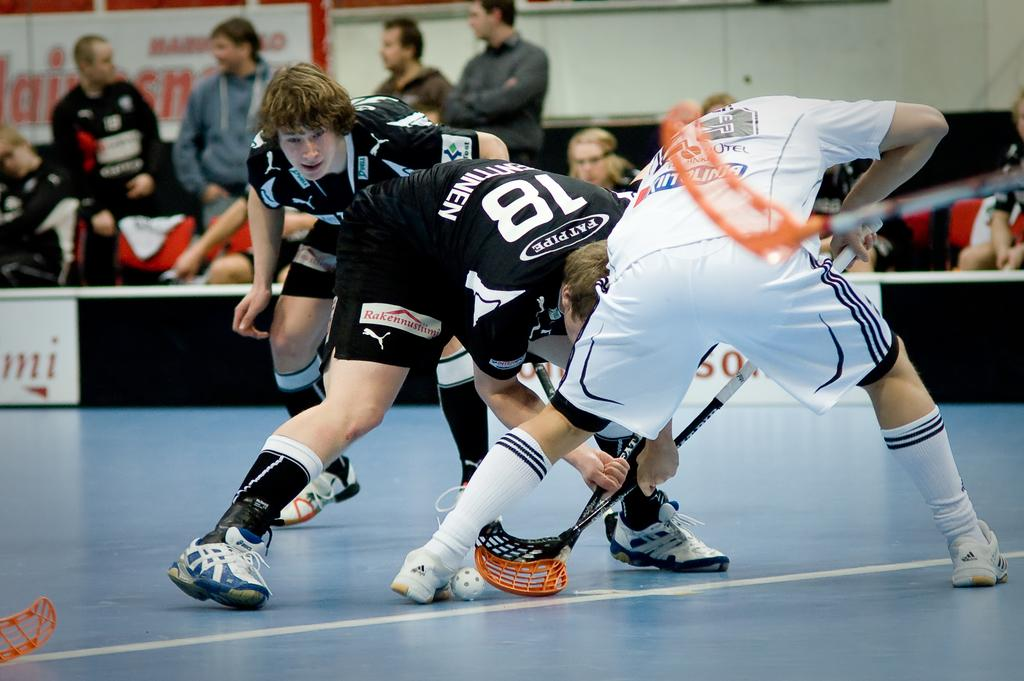<image>
Describe the image concisely. Two athletes pose for a faceoff, one in a black jersey sponsored by Fat Pipe. 